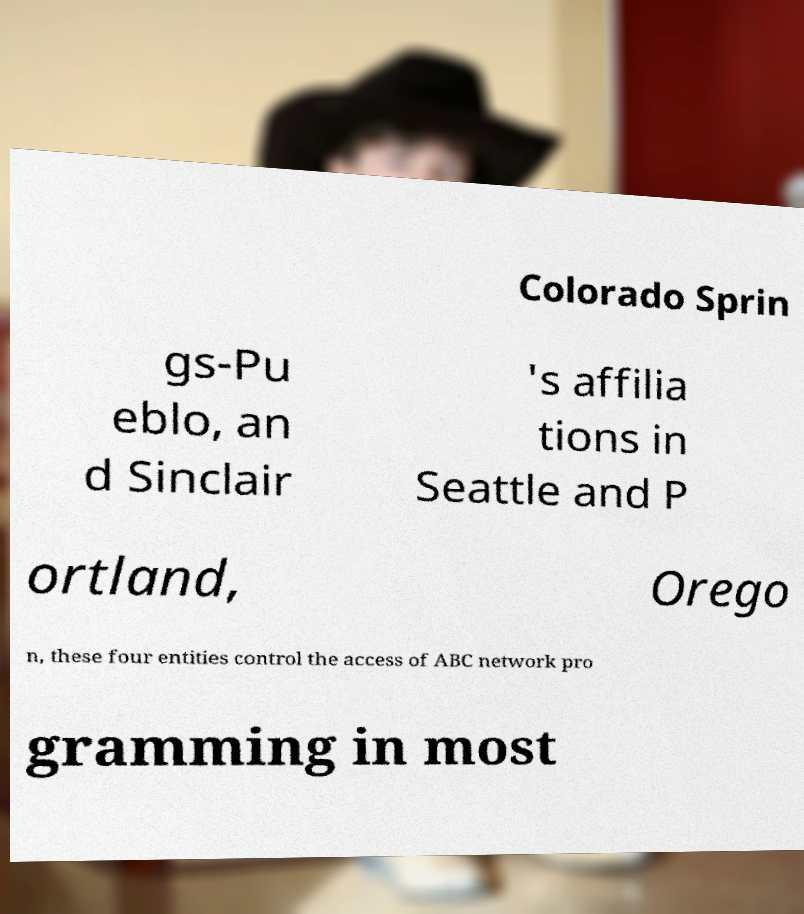For documentation purposes, I need the text within this image transcribed. Could you provide that? Colorado Sprin gs-Pu eblo, an d Sinclair 's affilia tions in Seattle and P ortland, Orego n, these four entities control the access of ABC network pro gramming in most 